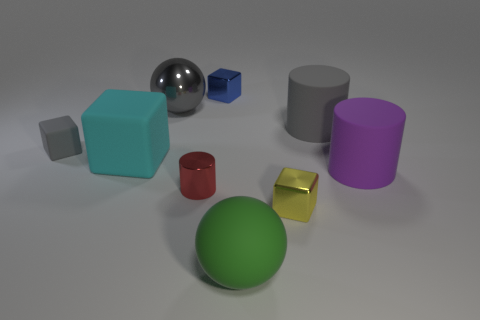What could be the function of the green sphere in a practical setting? The green sphere might be a model used in educational contexts to illustrate geometric concepts, or it could serve as a decorative element due to its pleasing color and simple shape. Could it serve any specific purpose apart from decoration or education? Depending on its material and weight, it could also be used as a prop in physical therapy exercises to improve coordination and motor skills. 